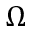Convert formula to latex. <formula><loc_0><loc_0><loc_500><loc_500>\Omega</formula> 